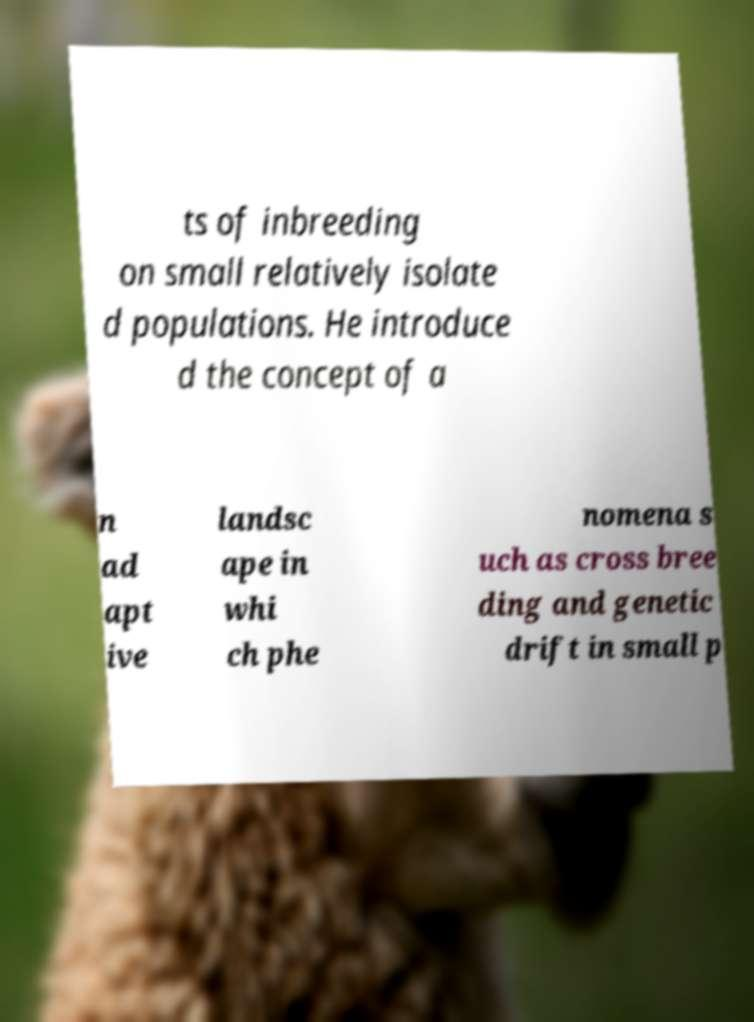Can you read and provide the text displayed in the image?This photo seems to have some interesting text. Can you extract and type it out for me? ts of inbreeding on small relatively isolate d populations. He introduce d the concept of a n ad apt ive landsc ape in whi ch phe nomena s uch as cross bree ding and genetic drift in small p 